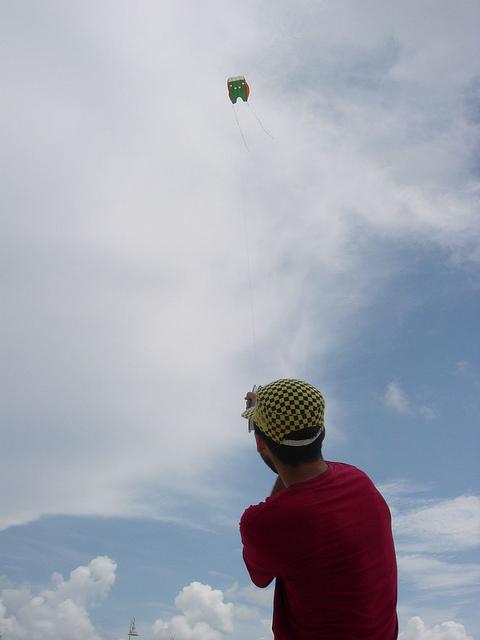What color is the man's shirt?
Be succinct. Red. Is the young man wearing his hat backwards?
Be succinct. No. Is the kite happy?
Short answer required. No. Is the man's hat checkerboard?
Quick response, please. Yes. Is this photo in the ocean?
Give a very brief answer. No. What is on the person's head?
Be succinct. Hat. What is in the air?
Give a very brief answer. Kite. 